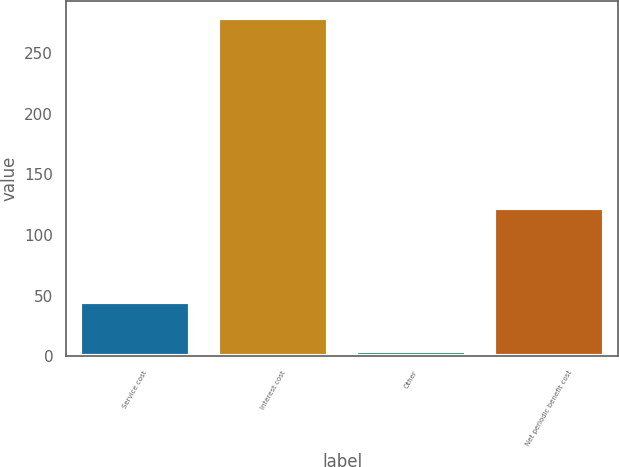Convert chart to OTSL. <chart><loc_0><loc_0><loc_500><loc_500><bar_chart><fcel>Service cost<fcel>Interest cost<fcel>Other<fcel>Net periodic benefit cost<nl><fcel>45<fcel>279<fcel>4<fcel>122<nl></chart> 